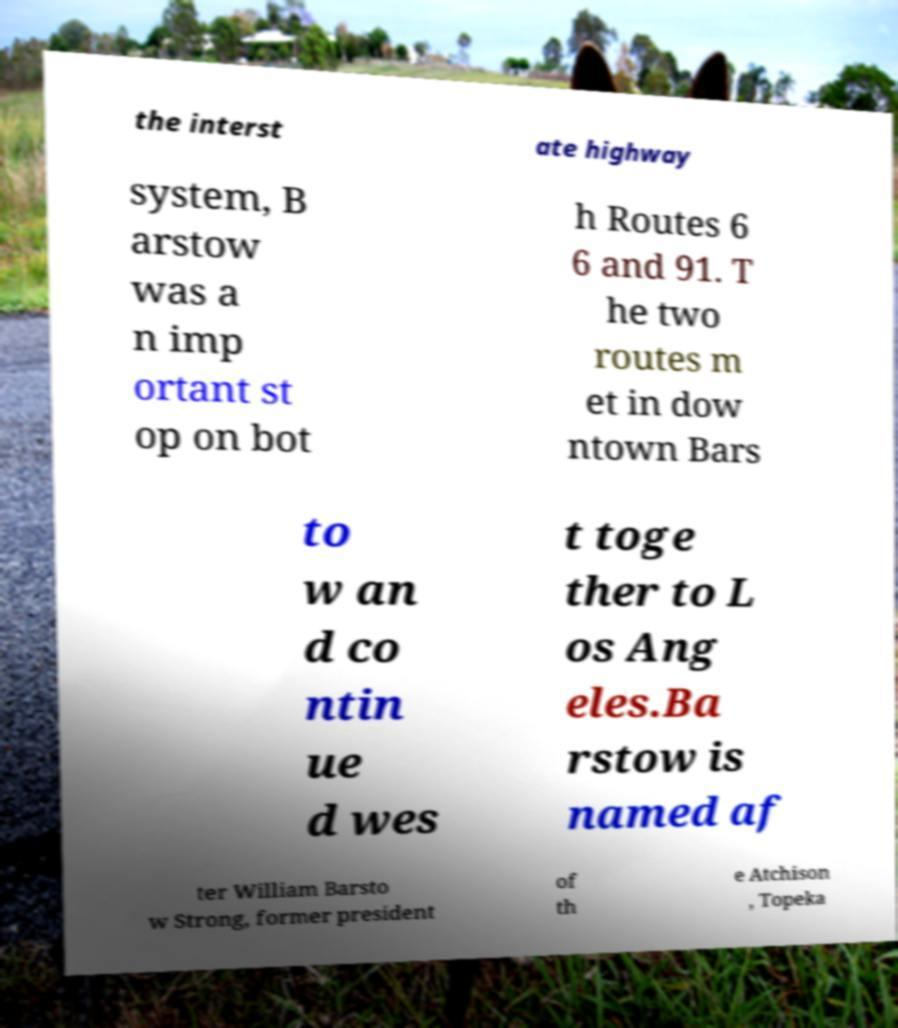Please identify and transcribe the text found in this image. the interst ate highway system, B arstow was a n imp ortant st op on bot h Routes 6 6 and 91. T he two routes m et in dow ntown Bars to w an d co ntin ue d wes t toge ther to L os Ang eles.Ba rstow is named af ter William Barsto w Strong, former president of th e Atchison , Topeka 